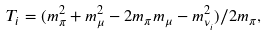Convert formula to latex. <formula><loc_0><loc_0><loc_500><loc_500>T _ { i } = ( m _ { \pi } ^ { 2 } + m _ { \mu } ^ { 2 } - 2 m _ { \pi } m _ { \mu } - m _ { \nu _ { i } } ^ { 2 } ) / 2 m _ { \pi } ,</formula> 